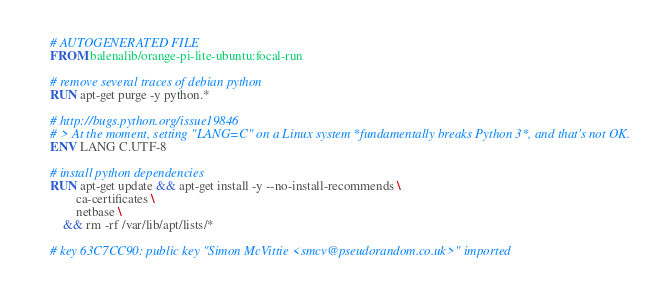<code> <loc_0><loc_0><loc_500><loc_500><_Dockerfile_># AUTOGENERATED FILE
FROM balenalib/orange-pi-lite-ubuntu:focal-run

# remove several traces of debian python
RUN apt-get purge -y python.*

# http://bugs.python.org/issue19846
# > At the moment, setting "LANG=C" on a Linux system *fundamentally breaks Python 3*, and that's not OK.
ENV LANG C.UTF-8

# install python dependencies
RUN apt-get update && apt-get install -y --no-install-recommends \
		ca-certificates \
		netbase \
	&& rm -rf /var/lib/apt/lists/*

# key 63C7CC90: public key "Simon McVittie <smcv@pseudorandom.co.uk>" imported</code> 